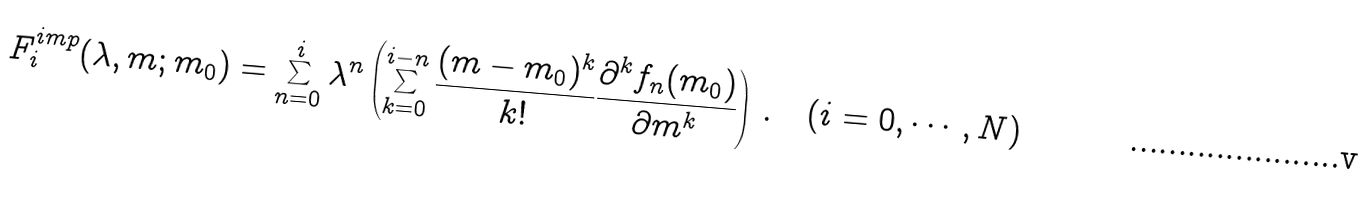Convert formula to latex. <formula><loc_0><loc_0><loc_500><loc_500>F _ { i } ^ { i m p } ( \lambda , m ; m _ { 0 } ) = \sum _ { n = 0 } ^ { i } \lambda ^ { n } \left ( \sum _ { k = 0 } ^ { i - n } \frac { ( m - m _ { 0 } ) ^ { k } } { k ! } \frac { \partial ^ { k } f _ { n } ( m _ { 0 } ) } { \partial m ^ { k } } \right ) \, . \quad ( i = 0 , \cdots , N )</formula> 